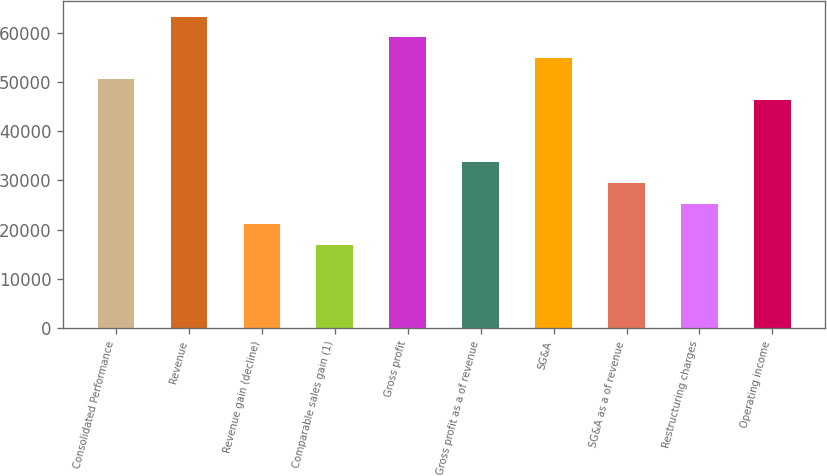Convert chart. <chart><loc_0><loc_0><loc_500><loc_500><bar_chart><fcel>Consolidated Performance<fcel>Revenue<fcel>Revenue gain (decline)<fcel>Comparable sales gain (1)<fcel>Gross profit<fcel>Gross profit as a of revenue<fcel>SG&A<fcel>SG&A as a of revenue<fcel>Restructuring charges<fcel>Operating income<nl><fcel>50581<fcel>63226<fcel>21076<fcel>16861<fcel>59011<fcel>33721<fcel>54796<fcel>29506<fcel>25291<fcel>46366<nl></chart> 